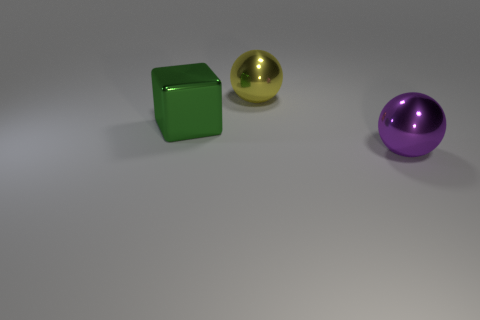How many other big blocks are made of the same material as the green cube?
Make the answer very short. 0. Are there the same number of green blocks that are in front of the large green block and metallic balls?
Your answer should be very brief. No. What size is the shiny ball behind the green shiny block?
Keep it short and to the point. Large. How many small objects are cyan matte spheres or yellow metal objects?
Provide a short and direct response. 0. What is the color of the other metallic object that is the same shape as the large yellow thing?
Provide a short and direct response. Purple. Do the yellow metal thing and the purple thing have the same size?
Offer a very short reply. Yes. How many things are tiny cyan rubber cylinders or shiny things on the right side of the yellow ball?
Provide a succinct answer. 1. What color is the thing left of the metal ball left of the large purple sphere?
Give a very brief answer. Green. Does the big shiny object behind the green shiny cube have the same color as the block?
Offer a very short reply. No. What material is the big green object on the left side of the purple shiny thing?
Provide a succinct answer. Metal. 